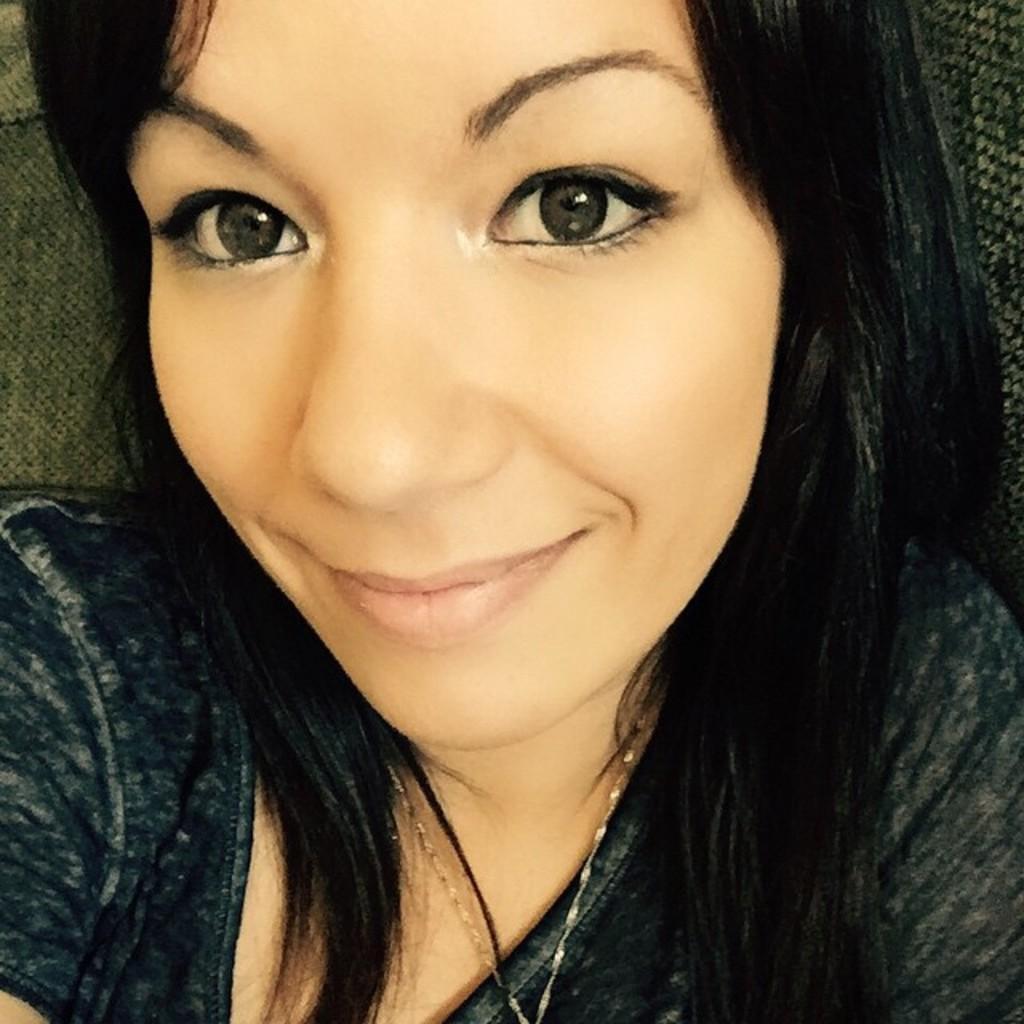Please provide a concise description of this image. In this image there is one women as we can see in middle of this image. 